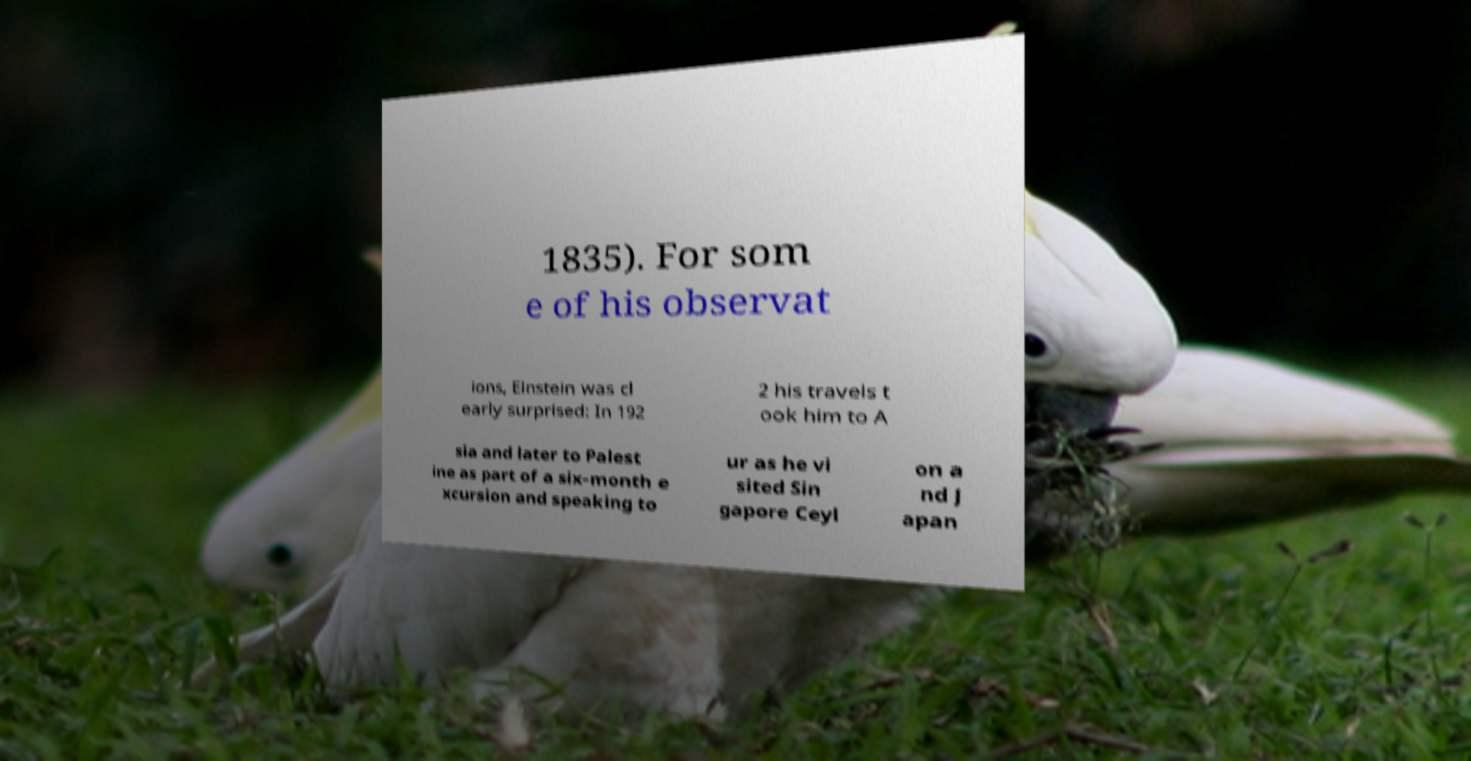Could you extract and type out the text from this image? 1835). For som e of his observat ions, Einstein was cl early surprised: In 192 2 his travels t ook him to A sia and later to Palest ine as part of a six-month e xcursion and speaking to ur as he vi sited Sin gapore Ceyl on a nd J apan 